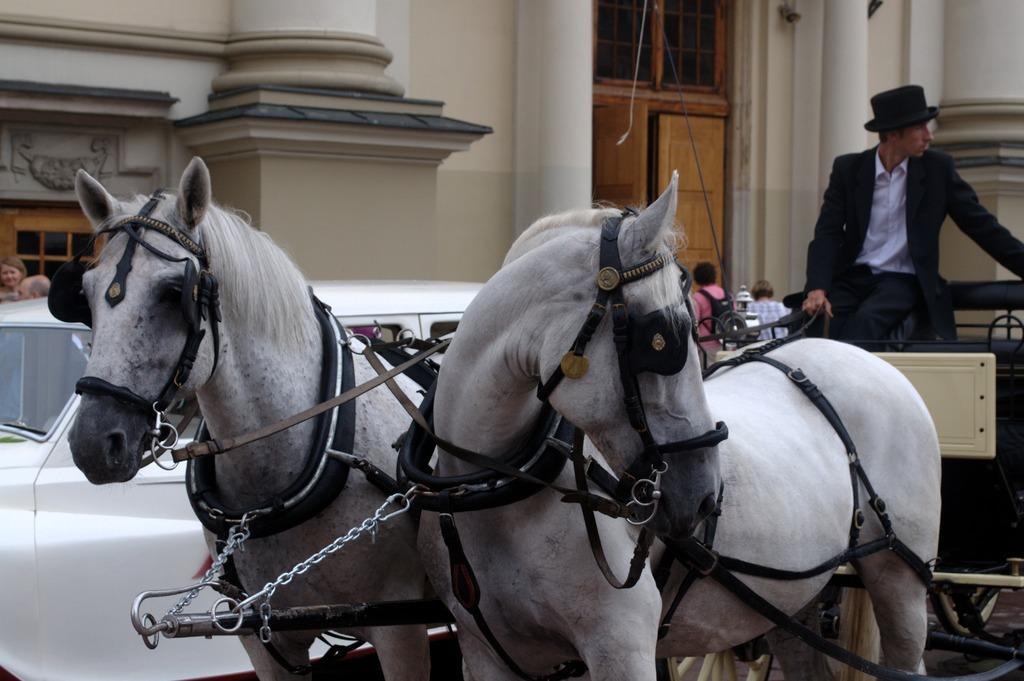Can you describe this image briefly? In this image I can see two horses and one person is riding them. In the background there are cars,people and the building. 